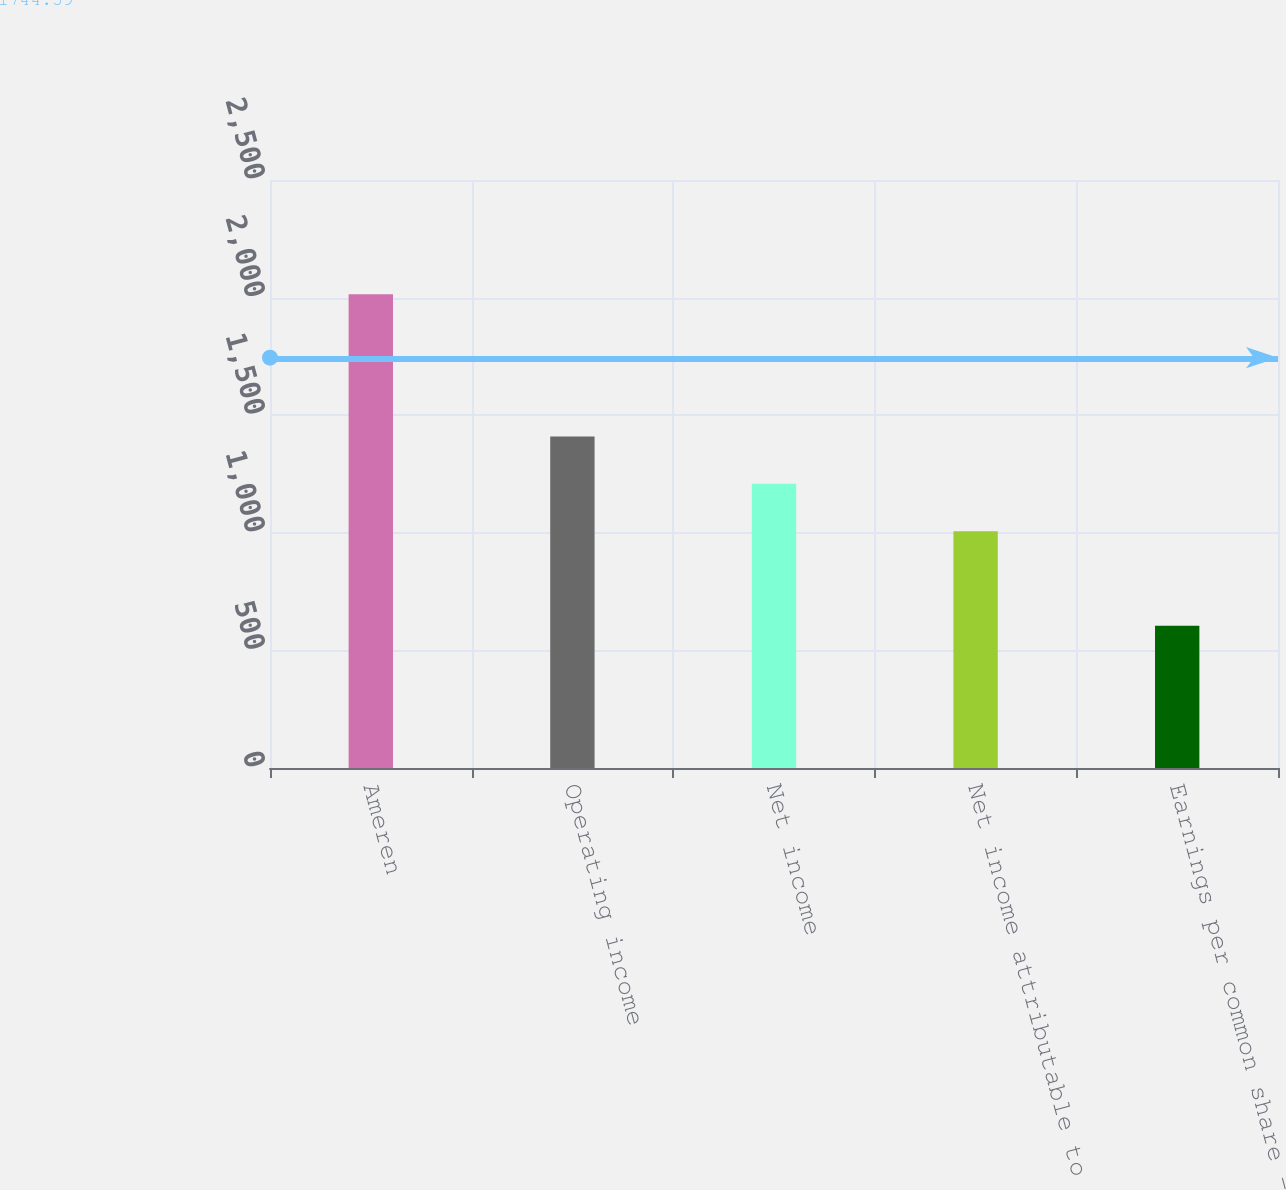Convert chart to OTSL. <chart><loc_0><loc_0><loc_500><loc_500><bar_chart><fcel>Ameren<fcel>Operating income<fcel>Net income<fcel>Net income attributable to<fcel>Earnings per common share -<nl><fcel>2014<fcel>1409.85<fcel>1208.47<fcel>1007.09<fcel>604.33<nl></chart> 